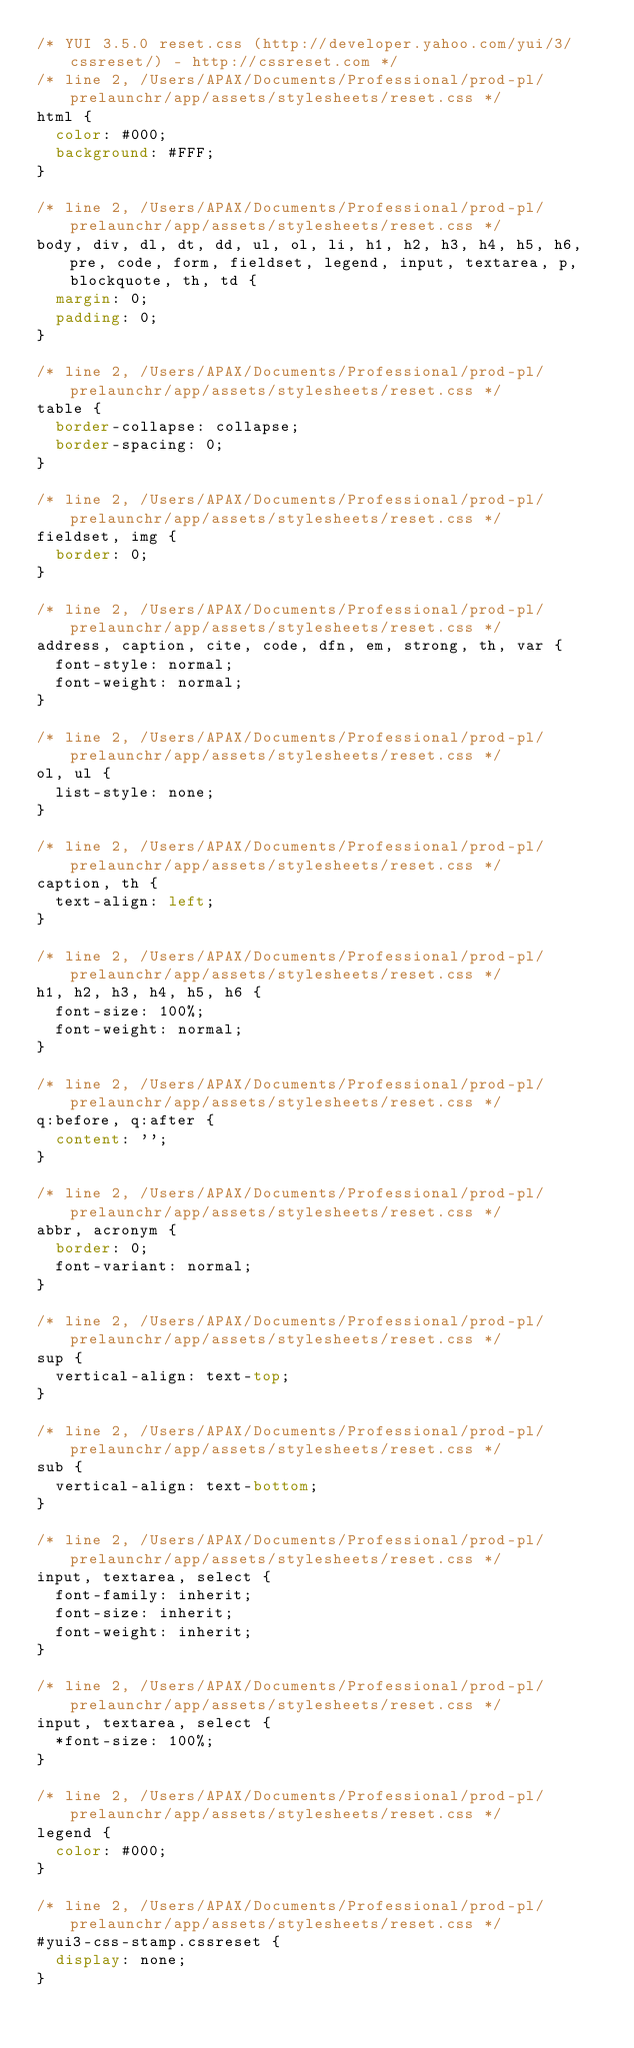<code> <loc_0><loc_0><loc_500><loc_500><_CSS_>/* YUI 3.5.0 reset.css (http://developer.yahoo.com/yui/3/cssreset/) - http://cssreset.com */
/* line 2, /Users/APAX/Documents/Professional/prod-pl/prelaunchr/app/assets/stylesheets/reset.css */
html {
  color: #000;
  background: #FFF;
}

/* line 2, /Users/APAX/Documents/Professional/prod-pl/prelaunchr/app/assets/stylesheets/reset.css */
body, div, dl, dt, dd, ul, ol, li, h1, h2, h3, h4, h5, h6, pre, code, form, fieldset, legend, input, textarea, p, blockquote, th, td {
  margin: 0;
  padding: 0;
}

/* line 2, /Users/APAX/Documents/Professional/prod-pl/prelaunchr/app/assets/stylesheets/reset.css */
table {
  border-collapse: collapse;
  border-spacing: 0;
}

/* line 2, /Users/APAX/Documents/Professional/prod-pl/prelaunchr/app/assets/stylesheets/reset.css */
fieldset, img {
  border: 0;
}

/* line 2, /Users/APAX/Documents/Professional/prod-pl/prelaunchr/app/assets/stylesheets/reset.css */
address, caption, cite, code, dfn, em, strong, th, var {
  font-style: normal;
  font-weight: normal;
}

/* line 2, /Users/APAX/Documents/Professional/prod-pl/prelaunchr/app/assets/stylesheets/reset.css */
ol, ul {
  list-style: none;
}

/* line 2, /Users/APAX/Documents/Professional/prod-pl/prelaunchr/app/assets/stylesheets/reset.css */
caption, th {
  text-align: left;
}

/* line 2, /Users/APAX/Documents/Professional/prod-pl/prelaunchr/app/assets/stylesheets/reset.css */
h1, h2, h3, h4, h5, h6 {
  font-size: 100%;
  font-weight: normal;
}

/* line 2, /Users/APAX/Documents/Professional/prod-pl/prelaunchr/app/assets/stylesheets/reset.css */
q:before, q:after {
  content: '';
}

/* line 2, /Users/APAX/Documents/Professional/prod-pl/prelaunchr/app/assets/stylesheets/reset.css */
abbr, acronym {
  border: 0;
  font-variant: normal;
}

/* line 2, /Users/APAX/Documents/Professional/prod-pl/prelaunchr/app/assets/stylesheets/reset.css */
sup {
  vertical-align: text-top;
}

/* line 2, /Users/APAX/Documents/Professional/prod-pl/prelaunchr/app/assets/stylesheets/reset.css */
sub {
  vertical-align: text-bottom;
}

/* line 2, /Users/APAX/Documents/Professional/prod-pl/prelaunchr/app/assets/stylesheets/reset.css */
input, textarea, select {
  font-family: inherit;
  font-size: inherit;
  font-weight: inherit;
}

/* line 2, /Users/APAX/Documents/Professional/prod-pl/prelaunchr/app/assets/stylesheets/reset.css */
input, textarea, select {
  *font-size: 100%;
}

/* line 2, /Users/APAX/Documents/Professional/prod-pl/prelaunchr/app/assets/stylesheets/reset.css */
legend {
  color: #000;
}

/* line 2, /Users/APAX/Documents/Professional/prod-pl/prelaunchr/app/assets/stylesheets/reset.css */
#yui3-css-stamp.cssreset {
  display: none;
}
</code> 